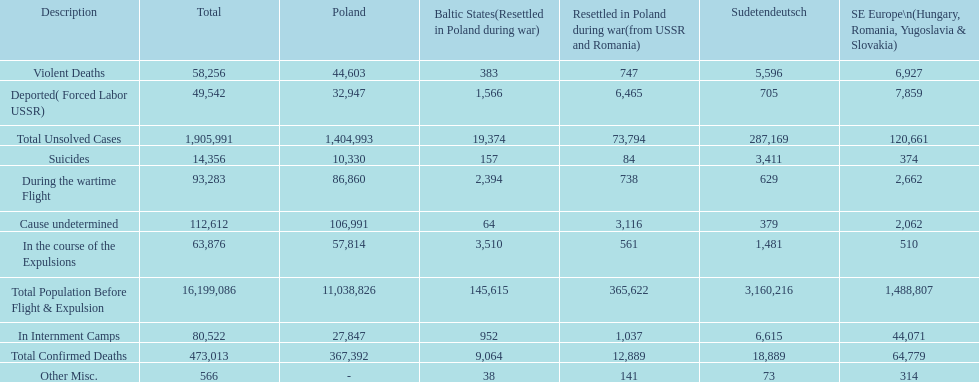Which region had the least total of unsolved cases? Baltic States(Resettled in Poland during war). 